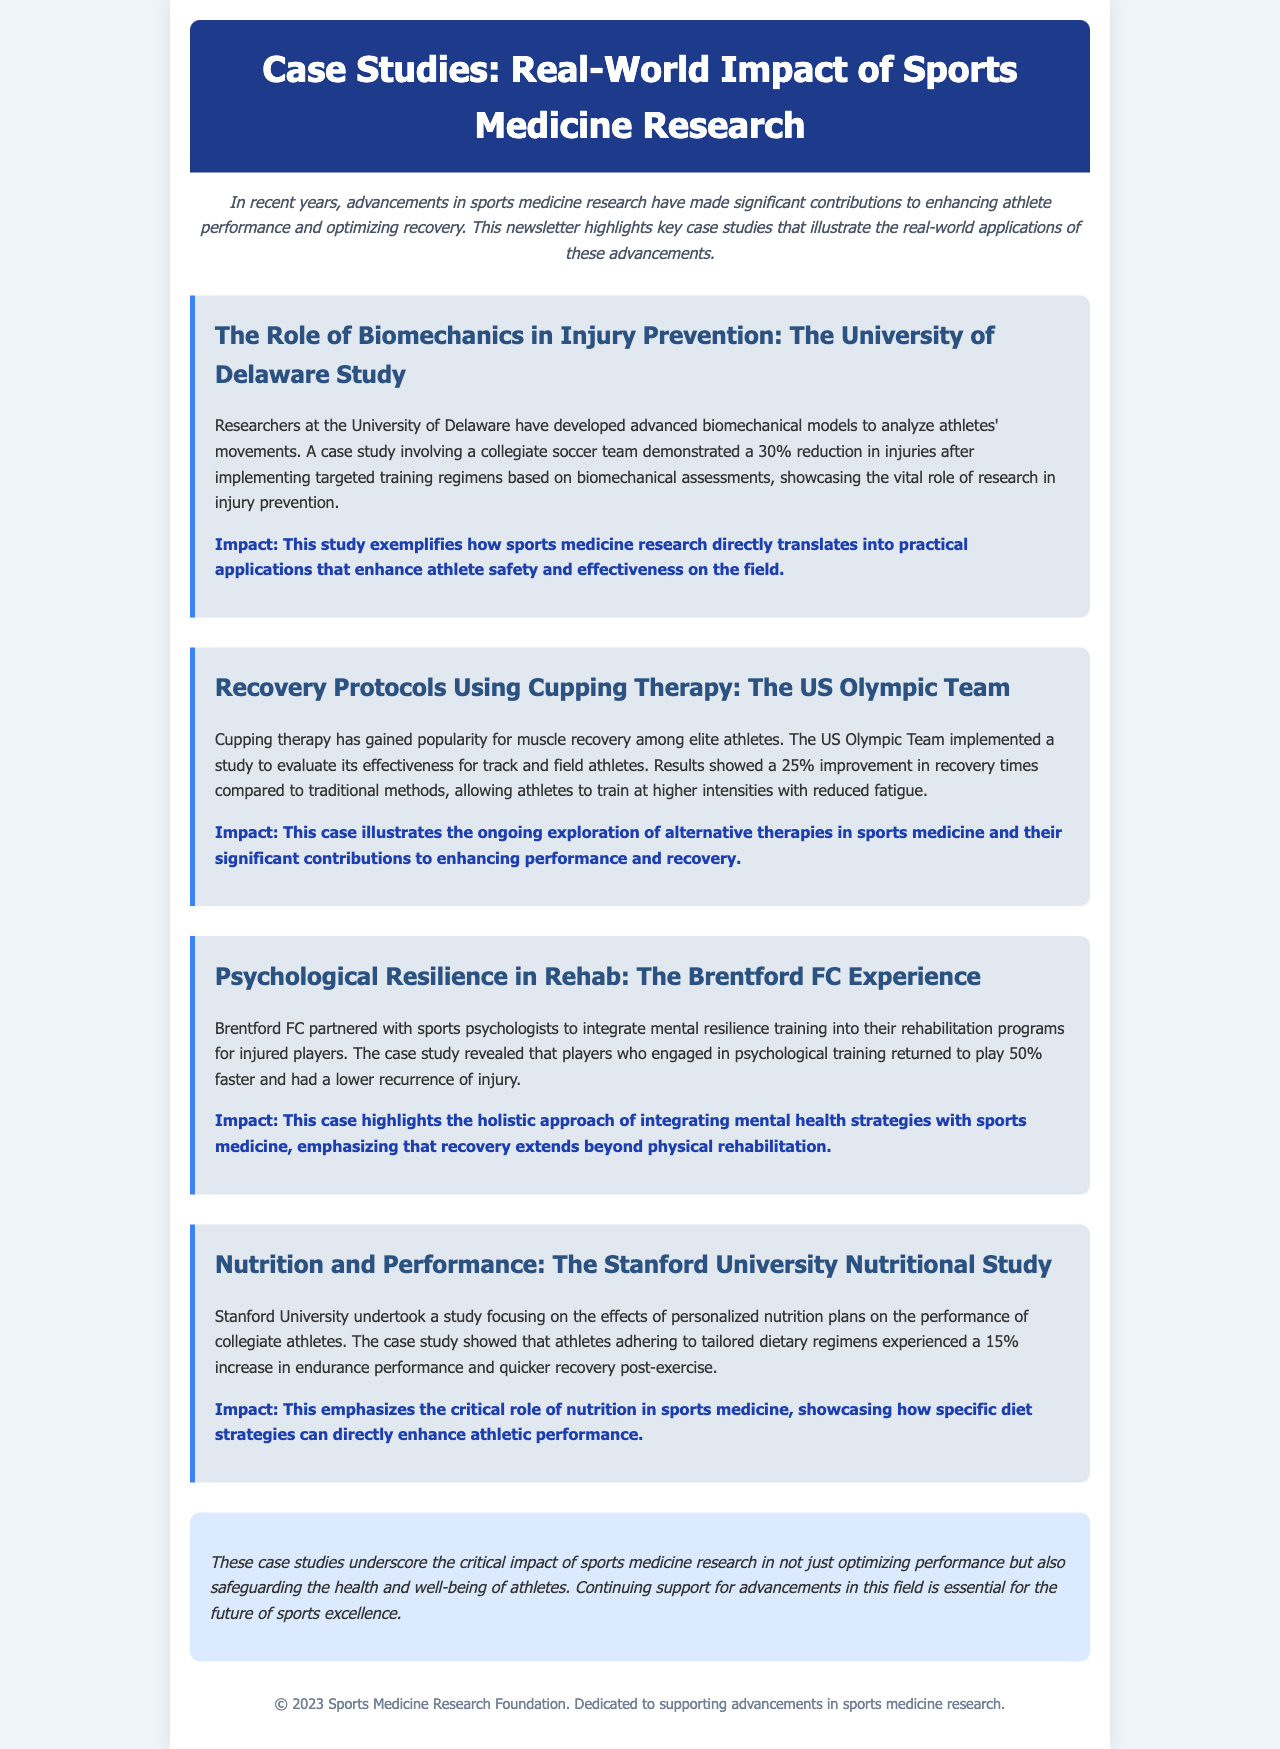What is the title of the newsletter? The title of the newsletter is presented in the header of the document.
Answer: Case Studies: Real-World Impact of Sports Medicine Research How much was the reduction in injuries for the collegiate soccer team? This information is highlighted in the case study discussing the University of Delaware study.
Answer: 30% What percentage improvement in recovery times did the US Olympic Team see with cupping therapy? This statistic is included in the section about the US Olympic Team's study.
Answer: 25% What was the return-to-play speed increase for players at Brentford FC who engaged in psychological training? This fact is stated in the case study concerning the integration of mental resilience training.
Answer: 50% What percentage increase in endurance was observed at Stanford University with personalized nutrition plans? This information is found in the case study about Stanford University's nutritional study.
Answer: 15% According to the newsletter, what is emphasized alongside physical rehabilitation? This concept is discussed in the context of Brentford FC's approach to rehab.
Answer: Mental health strategies What method was used by the US Olympic Team for recovery? This method is detailed in the specific case study about the US Olympic Team.
Answer: Cupping therapy What color is the header background of the newsletter? This can be identified by looking at the document's styling for the header.
Answer: Dark blue What role does sports medicine research play according to the conclusion? The conclusion summarizes the importance of research in enhancing athlete safety and performance.
Answer: Critical impact 